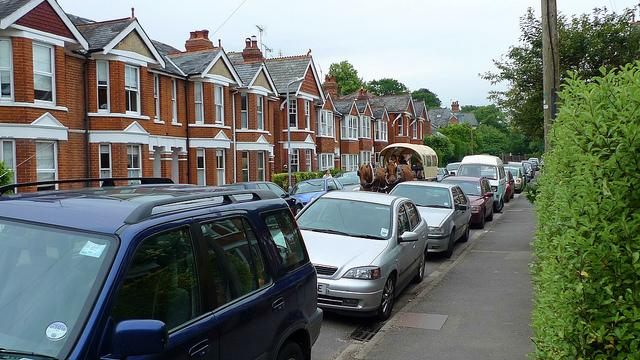Which conveyance pictured here uses less gas?

Choices:
A) truck
B) van
C) buggy
D) car buggy 